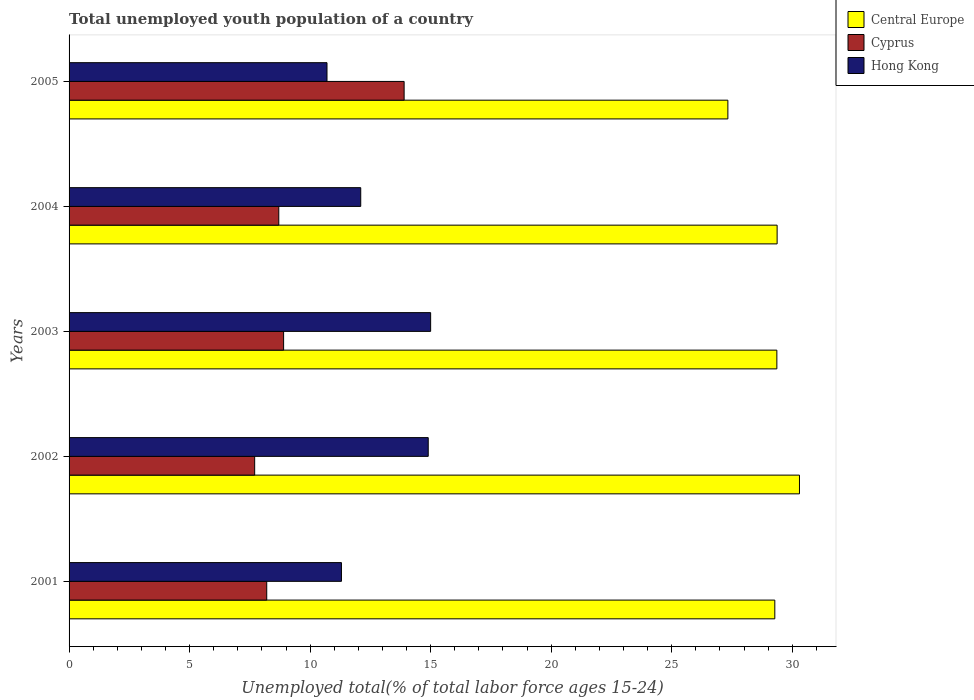How many groups of bars are there?
Your answer should be compact. 5. Are the number of bars on each tick of the Y-axis equal?
Offer a terse response. Yes. What is the label of the 5th group of bars from the top?
Ensure brevity in your answer.  2001. In how many cases, is the number of bars for a given year not equal to the number of legend labels?
Offer a terse response. 0. What is the percentage of total unemployed youth population of a country in Hong Kong in 2004?
Offer a terse response. 12.1. Across all years, what is the maximum percentage of total unemployed youth population of a country in Central Europe?
Ensure brevity in your answer.  30.3. Across all years, what is the minimum percentage of total unemployed youth population of a country in Cyprus?
Offer a terse response. 7.7. What is the total percentage of total unemployed youth population of a country in Central Europe in the graph?
Your response must be concise. 145.65. What is the difference between the percentage of total unemployed youth population of a country in Cyprus in 2001 and that in 2003?
Offer a terse response. -0.7. What is the difference between the percentage of total unemployed youth population of a country in Cyprus in 2003 and the percentage of total unemployed youth population of a country in Central Europe in 2002?
Your answer should be compact. -21.4. What is the average percentage of total unemployed youth population of a country in Hong Kong per year?
Your answer should be very brief. 12.8. In the year 2002, what is the difference between the percentage of total unemployed youth population of a country in Cyprus and percentage of total unemployed youth population of a country in Central Europe?
Provide a short and direct response. -22.6. In how many years, is the percentage of total unemployed youth population of a country in Hong Kong greater than 24 %?
Keep it short and to the point. 0. What is the ratio of the percentage of total unemployed youth population of a country in Hong Kong in 2003 to that in 2004?
Your answer should be very brief. 1.24. Is the difference between the percentage of total unemployed youth population of a country in Cyprus in 2001 and 2004 greater than the difference between the percentage of total unemployed youth population of a country in Central Europe in 2001 and 2004?
Your answer should be compact. No. What is the difference between the highest and the second highest percentage of total unemployed youth population of a country in Cyprus?
Your answer should be compact. 5. What is the difference between the highest and the lowest percentage of total unemployed youth population of a country in Cyprus?
Make the answer very short. 6.2. In how many years, is the percentage of total unemployed youth population of a country in Central Europe greater than the average percentage of total unemployed youth population of a country in Central Europe taken over all years?
Make the answer very short. 4. Is the sum of the percentage of total unemployed youth population of a country in Central Europe in 2001 and 2002 greater than the maximum percentage of total unemployed youth population of a country in Hong Kong across all years?
Give a very brief answer. Yes. What does the 3rd bar from the top in 2002 represents?
Provide a succinct answer. Central Europe. What does the 2nd bar from the bottom in 2003 represents?
Keep it short and to the point. Cyprus. How many years are there in the graph?
Ensure brevity in your answer.  5. What is the difference between two consecutive major ticks on the X-axis?
Offer a terse response. 5. Are the values on the major ticks of X-axis written in scientific E-notation?
Make the answer very short. No. Does the graph contain grids?
Provide a short and direct response. No. Where does the legend appear in the graph?
Offer a terse response. Top right. How many legend labels are there?
Your answer should be very brief. 3. What is the title of the graph?
Offer a very short reply. Total unemployed youth population of a country. What is the label or title of the X-axis?
Your answer should be very brief. Unemployed total(% of total labor force ages 15-24). What is the Unemployed total(% of total labor force ages 15-24) in Central Europe in 2001?
Provide a short and direct response. 29.28. What is the Unemployed total(% of total labor force ages 15-24) of Cyprus in 2001?
Your response must be concise. 8.2. What is the Unemployed total(% of total labor force ages 15-24) of Hong Kong in 2001?
Make the answer very short. 11.3. What is the Unemployed total(% of total labor force ages 15-24) of Central Europe in 2002?
Your answer should be very brief. 30.3. What is the Unemployed total(% of total labor force ages 15-24) of Cyprus in 2002?
Provide a succinct answer. 7.7. What is the Unemployed total(% of total labor force ages 15-24) of Hong Kong in 2002?
Keep it short and to the point. 14.9. What is the Unemployed total(% of total labor force ages 15-24) in Central Europe in 2003?
Ensure brevity in your answer.  29.36. What is the Unemployed total(% of total labor force ages 15-24) of Cyprus in 2003?
Give a very brief answer. 8.9. What is the Unemployed total(% of total labor force ages 15-24) of Hong Kong in 2003?
Provide a succinct answer. 15. What is the Unemployed total(% of total labor force ages 15-24) in Central Europe in 2004?
Keep it short and to the point. 29.37. What is the Unemployed total(% of total labor force ages 15-24) of Cyprus in 2004?
Provide a short and direct response. 8.7. What is the Unemployed total(% of total labor force ages 15-24) in Hong Kong in 2004?
Give a very brief answer. 12.1. What is the Unemployed total(% of total labor force ages 15-24) in Central Europe in 2005?
Ensure brevity in your answer.  27.33. What is the Unemployed total(% of total labor force ages 15-24) of Cyprus in 2005?
Give a very brief answer. 13.9. What is the Unemployed total(% of total labor force ages 15-24) in Hong Kong in 2005?
Ensure brevity in your answer.  10.7. Across all years, what is the maximum Unemployed total(% of total labor force ages 15-24) in Central Europe?
Give a very brief answer. 30.3. Across all years, what is the maximum Unemployed total(% of total labor force ages 15-24) in Cyprus?
Your answer should be very brief. 13.9. Across all years, what is the minimum Unemployed total(% of total labor force ages 15-24) of Central Europe?
Ensure brevity in your answer.  27.33. Across all years, what is the minimum Unemployed total(% of total labor force ages 15-24) of Cyprus?
Give a very brief answer. 7.7. Across all years, what is the minimum Unemployed total(% of total labor force ages 15-24) of Hong Kong?
Keep it short and to the point. 10.7. What is the total Unemployed total(% of total labor force ages 15-24) in Central Europe in the graph?
Make the answer very short. 145.65. What is the total Unemployed total(% of total labor force ages 15-24) of Cyprus in the graph?
Ensure brevity in your answer.  47.4. What is the difference between the Unemployed total(% of total labor force ages 15-24) of Central Europe in 2001 and that in 2002?
Offer a very short reply. -1.02. What is the difference between the Unemployed total(% of total labor force ages 15-24) in Cyprus in 2001 and that in 2002?
Your answer should be very brief. 0.5. What is the difference between the Unemployed total(% of total labor force ages 15-24) of Hong Kong in 2001 and that in 2002?
Make the answer very short. -3.6. What is the difference between the Unemployed total(% of total labor force ages 15-24) of Central Europe in 2001 and that in 2003?
Ensure brevity in your answer.  -0.09. What is the difference between the Unemployed total(% of total labor force ages 15-24) of Central Europe in 2001 and that in 2004?
Your answer should be very brief. -0.1. What is the difference between the Unemployed total(% of total labor force ages 15-24) in Central Europe in 2001 and that in 2005?
Make the answer very short. 1.95. What is the difference between the Unemployed total(% of total labor force ages 15-24) in Cyprus in 2001 and that in 2005?
Offer a terse response. -5.7. What is the difference between the Unemployed total(% of total labor force ages 15-24) in Central Europe in 2002 and that in 2003?
Provide a succinct answer. 0.94. What is the difference between the Unemployed total(% of total labor force ages 15-24) in Hong Kong in 2002 and that in 2003?
Provide a short and direct response. -0.1. What is the difference between the Unemployed total(% of total labor force ages 15-24) in Central Europe in 2002 and that in 2004?
Make the answer very short. 0.93. What is the difference between the Unemployed total(% of total labor force ages 15-24) of Hong Kong in 2002 and that in 2004?
Provide a short and direct response. 2.8. What is the difference between the Unemployed total(% of total labor force ages 15-24) in Central Europe in 2002 and that in 2005?
Offer a very short reply. 2.97. What is the difference between the Unemployed total(% of total labor force ages 15-24) in Cyprus in 2002 and that in 2005?
Provide a short and direct response. -6.2. What is the difference between the Unemployed total(% of total labor force ages 15-24) of Hong Kong in 2002 and that in 2005?
Ensure brevity in your answer.  4.2. What is the difference between the Unemployed total(% of total labor force ages 15-24) in Central Europe in 2003 and that in 2004?
Give a very brief answer. -0.01. What is the difference between the Unemployed total(% of total labor force ages 15-24) in Cyprus in 2003 and that in 2004?
Provide a short and direct response. 0.2. What is the difference between the Unemployed total(% of total labor force ages 15-24) in Hong Kong in 2003 and that in 2004?
Your answer should be compact. 2.9. What is the difference between the Unemployed total(% of total labor force ages 15-24) in Central Europe in 2003 and that in 2005?
Keep it short and to the point. 2.03. What is the difference between the Unemployed total(% of total labor force ages 15-24) of Cyprus in 2003 and that in 2005?
Provide a succinct answer. -5. What is the difference between the Unemployed total(% of total labor force ages 15-24) in Hong Kong in 2003 and that in 2005?
Offer a terse response. 4.3. What is the difference between the Unemployed total(% of total labor force ages 15-24) in Central Europe in 2004 and that in 2005?
Offer a terse response. 2.04. What is the difference between the Unemployed total(% of total labor force ages 15-24) of Hong Kong in 2004 and that in 2005?
Make the answer very short. 1.4. What is the difference between the Unemployed total(% of total labor force ages 15-24) in Central Europe in 2001 and the Unemployed total(% of total labor force ages 15-24) in Cyprus in 2002?
Keep it short and to the point. 21.58. What is the difference between the Unemployed total(% of total labor force ages 15-24) of Central Europe in 2001 and the Unemployed total(% of total labor force ages 15-24) of Hong Kong in 2002?
Your answer should be compact. 14.38. What is the difference between the Unemployed total(% of total labor force ages 15-24) in Central Europe in 2001 and the Unemployed total(% of total labor force ages 15-24) in Cyprus in 2003?
Give a very brief answer. 20.38. What is the difference between the Unemployed total(% of total labor force ages 15-24) in Central Europe in 2001 and the Unemployed total(% of total labor force ages 15-24) in Hong Kong in 2003?
Make the answer very short. 14.28. What is the difference between the Unemployed total(% of total labor force ages 15-24) of Cyprus in 2001 and the Unemployed total(% of total labor force ages 15-24) of Hong Kong in 2003?
Your response must be concise. -6.8. What is the difference between the Unemployed total(% of total labor force ages 15-24) in Central Europe in 2001 and the Unemployed total(% of total labor force ages 15-24) in Cyprus in 2004?
Provide a short and direct response. 20.58. What is the difference between the Unemployed total(% of total labor force ages 15-24) in Central Europe in 2001 and the Unemployed total(% of total labor force ages 15-24) in Hong Kong in 2004?
Provide a succinct answer. 17.18. What is the difference between the Unemployed total(% of total labor force ages 15-24) in Central Europe in 2001 and the Unemployed total(% of total labor force ages 15-24) in Cyprus in 2005?
Offer a very short reply. 15.38. What is the difference between the Unemployed total(% of total labor force ages 15-24) in Central Europe in 2001 and the Unemployed total(% of total labor force ages 15-24) in Hong Kong in 2005?
Provide a succinct answer. 18.58. What is the difference between the Unemployed total(% of total labor force ages 15-24) in Central Europe in 2002 and the Unemployed total(% of total labor force ages 15-24) in Cyprus in 2003?
Offer a very short reply. 21.4. What is the difference between the Unemployed total(% of total labor force ages 15-24) of Central Europe in 2002 and the Unemployed total(% of total labor force ages 15-24) of Hong Kong in 2003?
Make the answer very short. 15.3. What is the difference between the Unemployed total(% of total labor force ages 15-24) of Cyprus in 2002 and the Unemployed total(% of total labor force ages 15-24) of Hong Kong in 2003?
Make the answer very short. -7.3. What is the difference between the Unemployed total(% of total labor force ages 15-24) of Central Europe in 2002 and the Unemployed total(% of total labor force ages 15-24) of Cyprus in 2004?
Keep it short and to the point. 21.6. What is the difference between the Unemployed total(% of total labor force ages 15-24) in Central Europe in 2002 and the Unemployed total(% of total labor force ages 15-24) in Hong Kong in 2004?
Provide a short and direct response. 18.2. What is the difference between the Unemployed total(% of total labor force ages 15-24) in Central Europe in 2002 and the Unemployed total(% of total labor force ages 15-24) in Cyprus in 2005?
Keep it short and to the point. 16.4. What is the difference between the Unemployed total(% of total labor force ages 15-24) in Central Europe in 2002 and the Unemployed total(% of total labor force ages 15-24) in Hong Kong in 2005?
Your response must be concise. 19.6. What is the difference between the Unemployed total(% of total labor force ages 15-24) of Cyprus in 2002 and the Unemployed total(% of total labor force ages 15-24) of Hong Kong in 2005?
Keep it short and to the point. -3. What is the difference between the Unemployed total(% of total labor force ages 15-24) of Central Europe in 2003 and the Unemployed total(% of total labor force ages 15-24) of Cyprus in 2004?
Provide a short and direct response. 20.66. What is the difference between the Unemployed total(% of total labor force ages 15-24) in Central Europe in 2003 and the Unemployed total(% of total labor force ages 15-24) in Hong Kong in 2004?
Provide a succinct answer. 17.26. What is the difference between the Unemployed total(% of total labor force ages 15-24) in Central Europe in 2003 and the Unemployed total(% of total labor force ages 15-24) in Cyprus in 2005?
Provide a succinct answer. 15.46. What is the difference between the Unemployed total(% of total labor force ages 15-24) of Central Europe in 2003 and the Unemployed total(% of total labor force ages 15-24) of Hong Kong in 2005?
Offer a terse response. 18.66. What is the difference between the Unemployed total(% of total labor force ages 15-24) in Cyprus in 2003 and the Unemployed total(% of total labor force ages 15-24) in Hong Kong in 2005?
Offer a very short reply. -1.8. What is the difference between the Unemployed total(% of total labor force ages 15-24) of Central Europe in 2004 and the Unemployed total(% of total labor force ages 15-24) of Cyprus in 2005?
Your response must be concise. 15.47. What is the difference between the Unemployed total(% of total labor force ages 15-24) of Central Europe in 2004 and the Unemployed total(% of total labor force ages 15-24) of Hong Kong in 2005?
Your answer should be compact. 18.67. What is the average Unemployed total(% of total labor force ages 15-24) in Central Europe per year?
Offer a terse response. 29.13. What is the average Unemployed total(% of total labor force ages 15-24) in Cyprus per year?
Give a very brief answer. 9.48. What is the average Unemployed total(% of total labor force ages 15-24) of Hong Kong per year?
Give a very brief answer. 12.8. In the year 2001, what is the difference between the Unemployed total(% of total labor force ages 15-24) in Central Europe and Unemployed total(% of total labor force ages 15-24) in Cyprus?
Ensure brevity in your answer.  21.08. In the year 2001, what is the difference between the Unemployed total(% of total labor force ages 15-24) of Central Europe and Unemployed total(% of total labor force ages 15-24) of Hong Kong?
Provide a succinct answer. 17.98. In the year 2001, what is the difference between the Unemployed total(% of total labor force ages 15-24) of Cyprus and Unemployed total(% of total labor force ages 15-24) of Hong Kong?
Your answer should be compact. -3.1. In the year 2002, what is the difference between the Unemployed total(% of total labor force ages 15-24) of Central Europe and Unemployed total(% of total labor force ages 15-24) of Cyprus?
Ensure brevity in your answer.  22.6. In the year 2002, what is the difference between the Unemployed total(% of total labor force ages 15-24) of Central Europe and Unemployed total(% of total labor force ages 15-24) of Hong Kong?
Your response must be concise. 15.4. In the year 2002, what is the difference between the Unemployed total(% of total labor force ages 15-24) of Cyprus and Unemployed total(% of total labor force ages 15-24) of Hong Kong?
Provide a short and direct response. -7.2. In the year 2003, what is the difference between the Unemployed total(% of total labor force ages 15-24) in Central Europe and Unemployed total(% of total labor force ages 15-24) in Cyprus?
Offer a very short reply. 20.46. In the year 2003, what is the difference between the Unemployed total(% of total labor force ages 15-24) of Central Europe and Unemployed total(% of total labor force ages 15-24) of Hong Kong?
Offer a terse response. 14.36. In the year 2003, what is the difference between the Unemployed total(% of total labor force ages 15-24) in Cyprus and Unemployed total(% of total labor force ages 15-24) in Hong Kong?
Your answer should be compact. -6.1. In the year 2004, what is the difference between the Unemployed total(% of total labor force ages 15-24) of Central Europe and Unemployed total(% of total labor force ages 15-24) of Cyprus?
Keep it short and to the point. 20.67. In the year 2004, what is the difference between the Unemployed total(% of total labor force ages 15-24) of Central Europe and Unemployed total(% of total labor force ages 15-24) of Hong Kong?
Your answer should be very brief. 17.27. In the year 2004, what is the difference between the Unemployed total(% of total labor force ages 15-24) in Cyprus and Unemployed total(% of total labor force ages 15-24) in Hong Kong?
Offer a very short reply. -3.4. In the year 2005, what is the difference between the Unemployed total(% of total labor force ages 15-24) of Central Europe and Unemployed total(% of total labor force ages 15-24) of Cyprus?
Your answer should be compact. 13.43. In the year 2005, what is the difference between the Unemployed total(% of total labor force ages 15-24) in Central Europe and Unemployed total(% of total labor force ages 15-24) in Hong Kong?
Offer a terse response. 16.63. In the year 2005, what is the difference between the Unemployed total(% of total labor force ages 15-24) in Cyprus and Unemployed total(% of total labor force ages 15-24) in Hong Kong?
Keep it short and to the point. 3.2. What is the ratio of the Unemployed total(% of total labor force ages 15-24) in Central Europe in 2001 to that in 2002?
Give a very brief answer. 0.97. What is the ratio of the Unemployed total(% of total labor force ages 15-24) in Cyprus in 2001 to that in 2002?
Keep it short and to the point. 1.06. What is the ratio of the Unemployed total(% of total labor force ages 15-24) of Hong Kong in 2001 to that in 2002?
Give a very brief answer. 0.76. What is the ratio of the Unemployed total(% of total labor force ages 15-24) of Cyprus in 2001 to that in 2003?
Your answer should be compact. 0.92. What is the ratio of the Unemployed total(% of total labor force ages 15-24) of Hong Kong in 2001 to that in 2003?
Make the answer very short. 0.75. What is the ratio of the Unemployed total(% of total labor force ages 15-24) of Central Europe in 2001 to that in 2004?
Provide a short and direct response. 1. What is the ratio of the Unemployed total(% of total labor force ages 15-24) of Cyprus in 2001 to that in 2004?
Your response must be concise. 0.94. What is the ratio of the Unemployed total(% of total labor force ages 15-24) of Hong Kong in 2001 to that in 2004?
Provide a succinct answer. 0.93. What is the ratio of the Unemployed total(% of total labor force ages 15-24) of Central Europe in 2001 to that in 2005?
Your answer should be very brief. 1.07. What is the ratio of the Unemployed total(% of total labor force ages 15-24) of Cyprus in 2001 to that in 2005?
Provide a short and direct response. 0.59. What is the ratio of the Unemployed total(% of total labor force ages 15-24) in Hong Kong in 2001 to that in 2005?
Your response must be concise. 1.06. What is the ratio of the Unemployed total(% of total labor force ages 15-24) in Central Europe in 2002 to that in 2003?
Keep it short and to the point. 1.03. What is the ratio of the Unemployed total(% of total labor force ages 15-24) of Cyprus in 2002 to that in 2003?
Your answer should be very brief. 0.87. What is the ratio of the Unemployed total(% of total labor force ages 15-24) of Central Europe in 2002 to that in 2004?
Keep it short and to the point. 1.03. What is the ratio of the Unemployed total(% of total labor force ages 15-24) of Cyprus in 2002 to that in 2004?
Make the answer very short. 0.89. What is the ratio of the Unemployed total(% of total labor force ages 15-24) of Hong Kong in 2002 to that in 2004?
Your answer should be compact. 1.23. What is the ratio of the Unemployed total(% of total labor force ages 15-24) in Central Europe in 2002 to that in 2005?
Offer a very short reply. 1.11. What is the ratio of the Unemployed total(% of total labor force ages 15-24) in Cyprus in 2002 to that in 2005?
Your answer should be compact. 0.55. What is the ratio of the Unemployed total(% of total labor force ages 15-24) of Hong Kong in 2002 to that in 2005?
Keep it short and to the point. 1.39. What is the ratio of the Unemployed total(% of total labor force ages 15-24) of Central Europe in 2003 to that in 2004?
Ensure brevity in your answer.  1. What is the ratio of the Unemployed total(% of total labor force ages 15-24) in Cyprus in 2003 to that in 2004?
Offer a very short reply. 1.02. What is the ratio of the Unemployed total(% of total labor force ages 15-24) in Hong Kong in 2003 to that in 2004?
Provide a succinct answer. 1.24. What is the ratio of the Unemployed total(% of total labor force ages 15-24) of Central Europe in 2003 to that in 2005?
Ensure brevity in your answer.  1.07. What is the ratio of the Unemployed total(% of total labor force ages 15-24) of Cyprus in 2003 to that in 2005?
Your response must be concise. 0.64. What is the ratio of the Unemployed total(% of total labor force ages 15-24) of Hong Kong in 2003 to that in 2005?
Give a very brief answer. 1.4. What is the ratio of the Unemployed total(% of total labor force ages 15-24) in Central Europe in 2004 to that in 2005?
Offer a terse response. 1.07. What is the ratio of the Unemployed total(% of total labor force ages 15-24) in Cyprus in 2004 to that in 2005?
Your response must be concise. 0.63. What is the ratio of the Unemployed total(% of total labor force ages 15-24) in Hong Kong in 2004 to that in 2005?
Offer a terse response. 1.13. What is the difference between the highest and the second highest Unemployed total(% of total labor force ages 15-24) of Central Europe?
Your answer should be very brief. 0.93. What is the difference between the highest and the second highest Unemployed total(% of total labor force ages 15-24) of Cyprus?
Your answer should be very brief. 5. What is the difference between the highest and the second highest Unemployed total(% of total labor force ages 15-24) of Hong Kong?
Your answer should be compact. 0.1. What is the difference between the highest and the lowest Unemployed total(% of total labor force ages 15-24) of Central Europe?
Ensure brevity in your answer.  2.97. What is the difference between the highest and the lowest Unemployed total(% of total labor force ages 15-24) of Cyprus?
Your answer should be very brief. 6.2. What is the difference between the highest and the lowest Unemployed total(% of total labor force ages 15-24) of Hong Kong?
Offer a terse response. 4.3. 